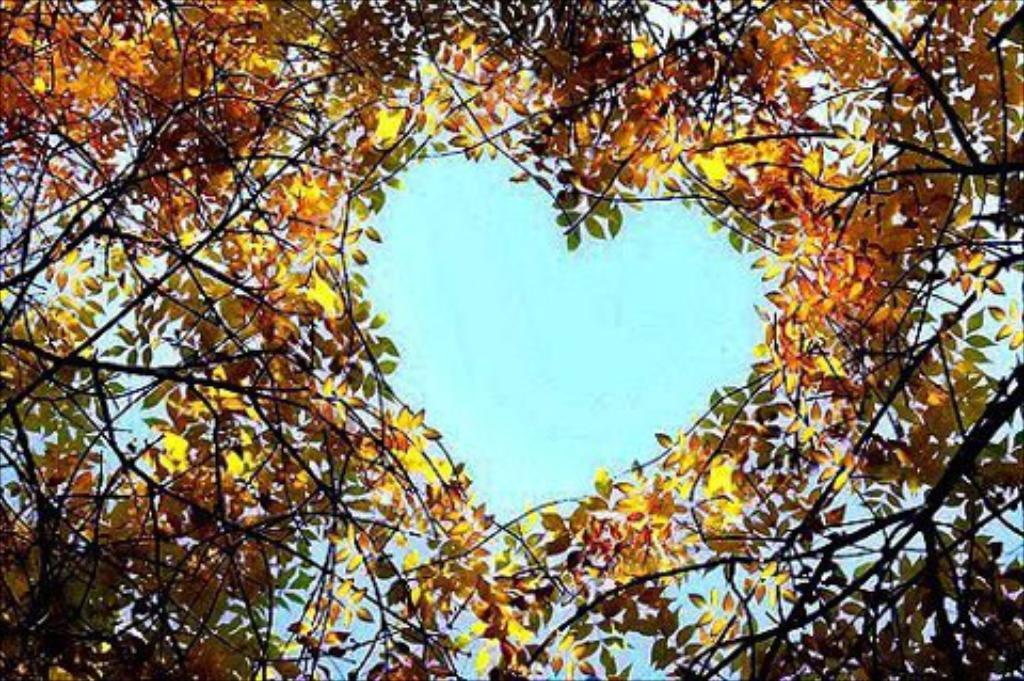What type of plant is visible in the image? There is a plant with twigs in the image. How are the twigs arranged in the image? The twigs form a heart shape in the middle. What can be seen in the background of the image? The sky is visible in the image. How does the plant control the sense of fight in the image? The plant does not control any sense of fight in the image, as it is a plant with twigs arranged in a heart shape, and there is no indication of any conflict or fighting. 